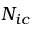<formula> <loc_0><loc_0><loc_500><loc_500>N _ { i c }</formula> 